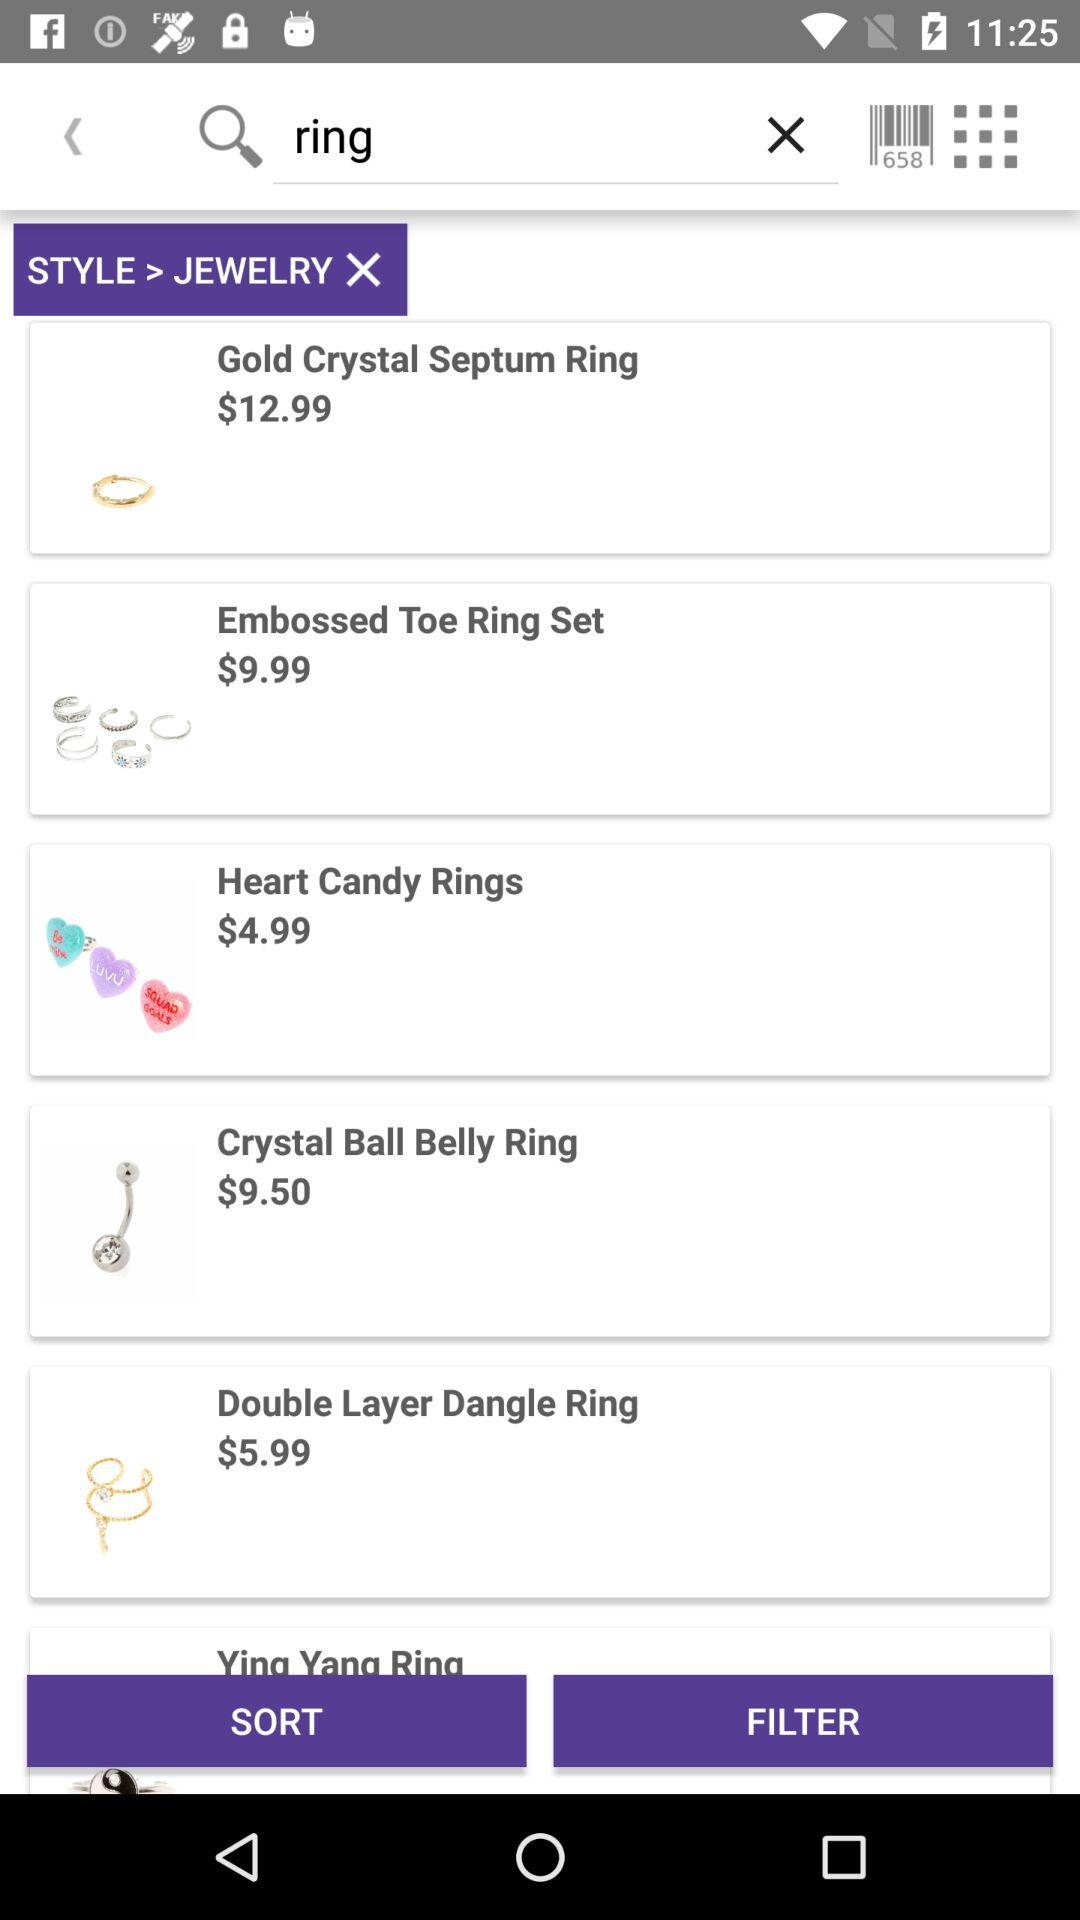What jewelry price is $4.99? The jewelry is " Heart Candy Rings". 